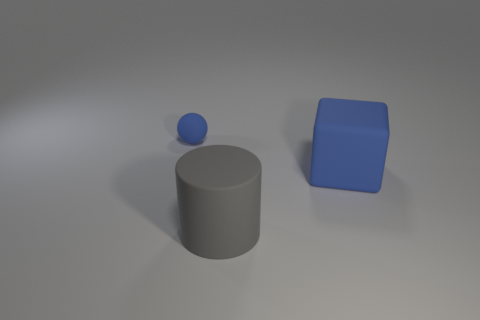Add 2 tiny blue matte objects. How many objects exist? 5 Add 1 big rubber blocks. How many big rubber blocks are left? 2 Add 1 big matte spheres. How many big matte spheres exist? 1 Subtract 0 red cylinders. How many objects are left? 3 Subtract all cylinders. How many objects are left? 2 Subtract all cyan cylinders. Subtract all cyan blocks. How many cylinders are left? 1 Subtract all gray metal cubes. Subtract all large blue matte objects. How many objects are left? 2 